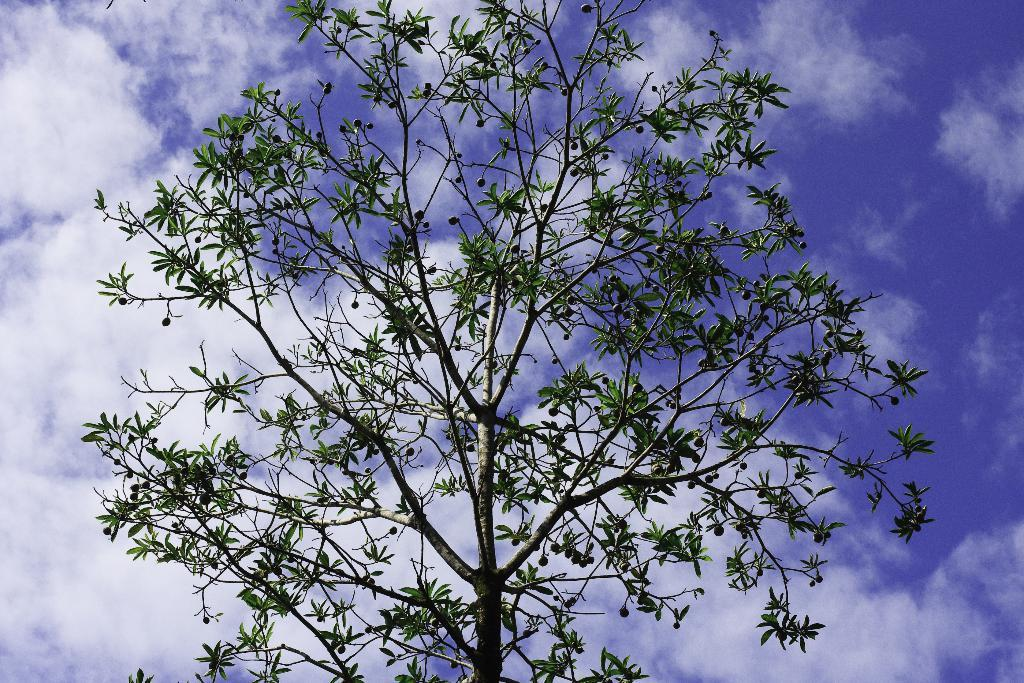What is the main object in the image? There is a tree in the image. What is the condition of the fruits on the tree? The tree has raw fruits on it. What can be seen in the sky in the image? There are clouds visible in the sky. What type of lawyer is sitting on the bed in the image? There is no bed or lawyer present in the image; it only features a tree with raw fruits and clouds in the sky. 